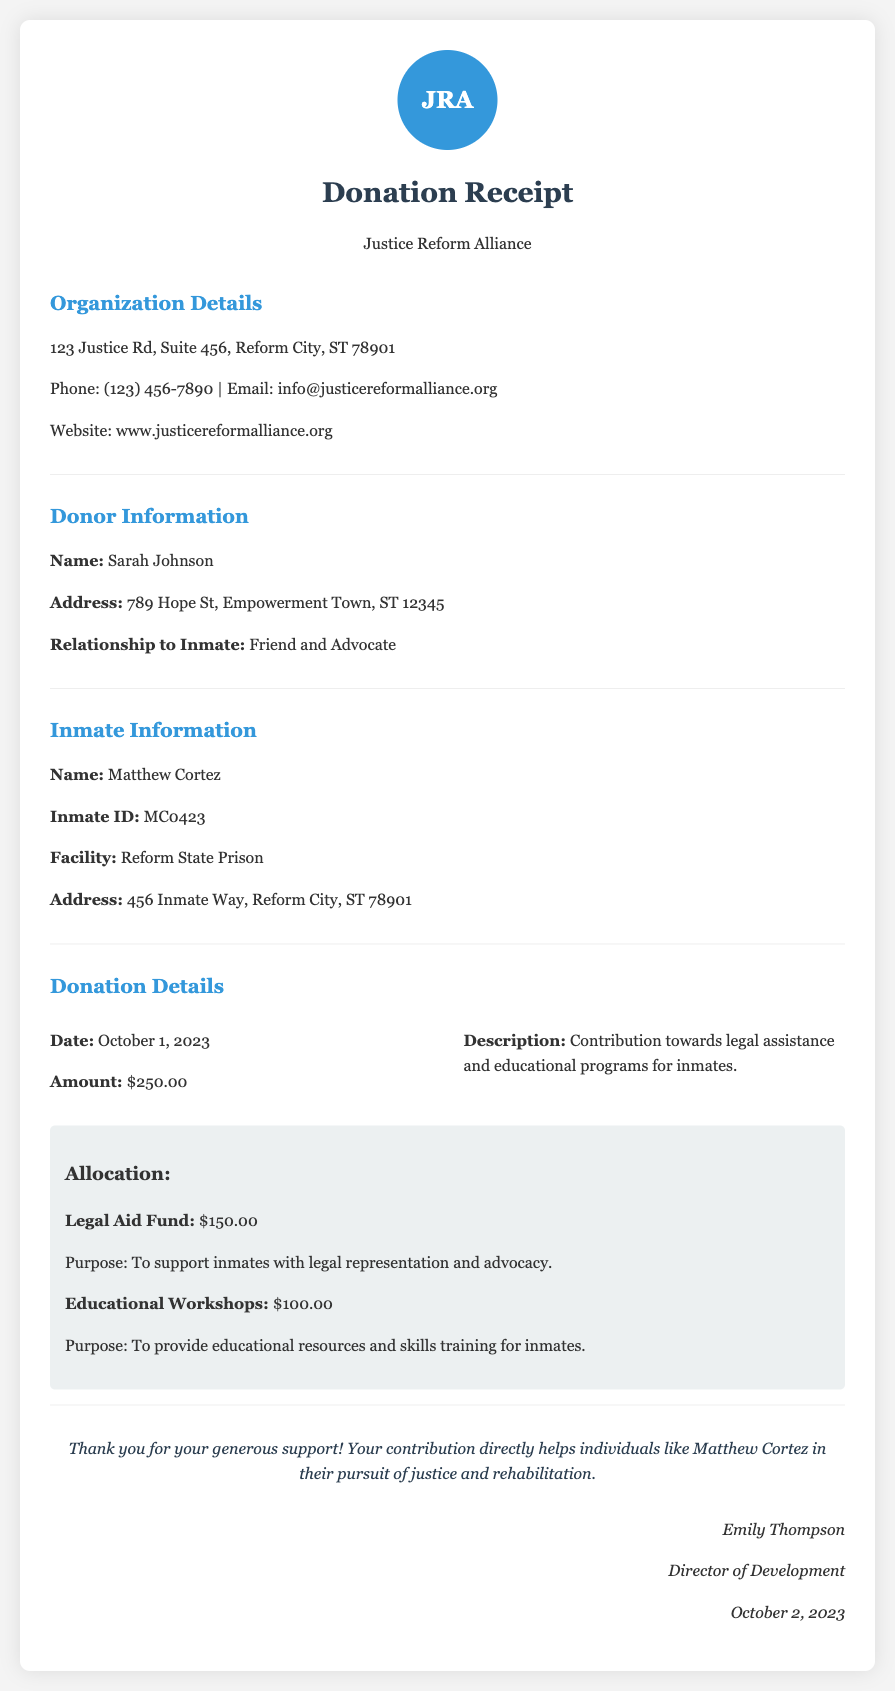What is the name of the organization? The name of the organization is mentioned at the top of the document as Justice Reform Alliance.
Answer: Justice Reform Alliance What is the date of the donation? The donation date can be found in the Donation Details section of the document as October 1, 2023.
Answer: October 1, 2023 Who made the donation? The donor's name is provided in the Donor Information section, identifying them as Sarah Johnson.
Answer: Sarah Johnson How much was donated? The donation amount is specified in the Donation Details section, indicating a contribution of $250.00.
Answer: $250.00 What is the purpose of the Legal Aid Fund? The purpose of the Legal Aid Fund is stated in the allocation section, which supports inmates with legal representation and advocacy.
Answer: To support inmates with legal representation and advocacy What is the relationship of the donor to the inmate? The relationship is noted in the Donor Information section, describing Sarah Johnson as a Friend and Advocate.
Answer: Friend and Advocate How much funding was allocated for Educational Workshops? The amount allocated for Educational Workshops is provided in the allocation section as $100.00.
Answer: $100.00 Who is the Director of Development? The signature section reflects that Emily Thompson is the Director of Development.
Answer: Emily Thompson What facility is the inmate associated with? The facility where Matthew Cortez is held is located in the Inmate Information section as Reform State Prison.
Answer: Reform State Prison 